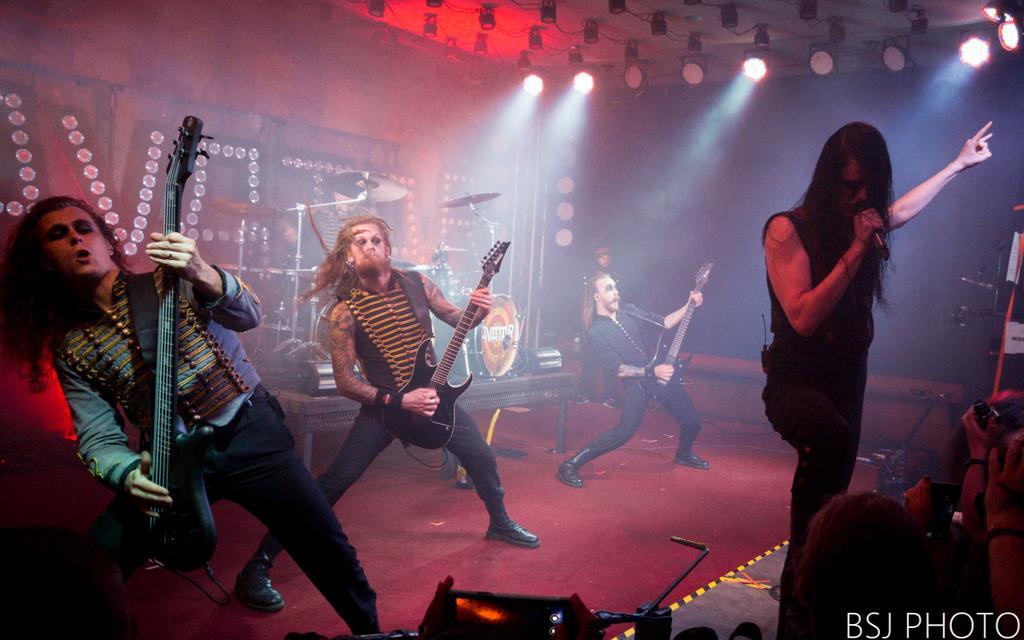Describe this image in one or two sentences. In this picture we can see a band performing. On the right there is a person holding mic. In the middle we can see people playing guitar. In the background there are lights, drums, person and wall. At the top there are lights. In the foreground there are some objects. Towards right we can see people's hands. 